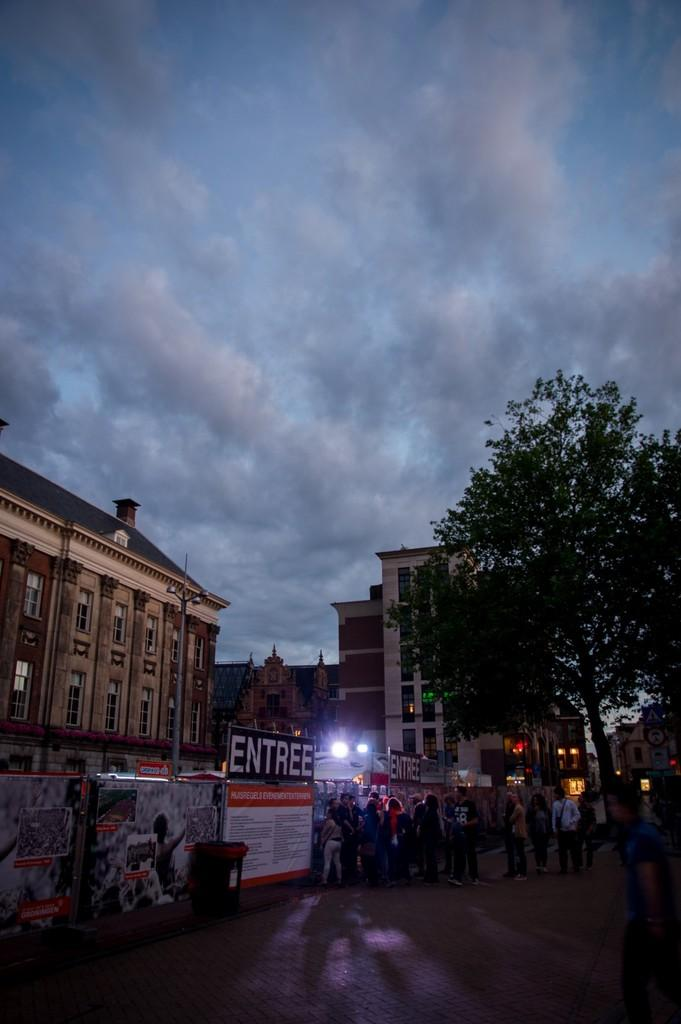How many people can be seen in the image? There are people in the image, but the exact number is not specified. What type of illumination is present in the image? There are lights in the image. What type of decorations or advertisements are present in the image? There are posters in the image. What type of written information is present in the image? There is text in the image. What type of natural elements are present in the image? There are trees in the image. What type of man-made structures are present in the image? There are buildings in the image. What part of the natural environment is visible in the image? The sky is visible in the image. What type of atmospheric conditions can be seen in the sky? There are clouds in the image. What type of transportation infrastructure is present in the image? There is a road at the bottom of the image. Where is the doll located in the image? There is no doll present in the image. What type of burial ground can be seen in the image? There is no cemetery present in the image. 